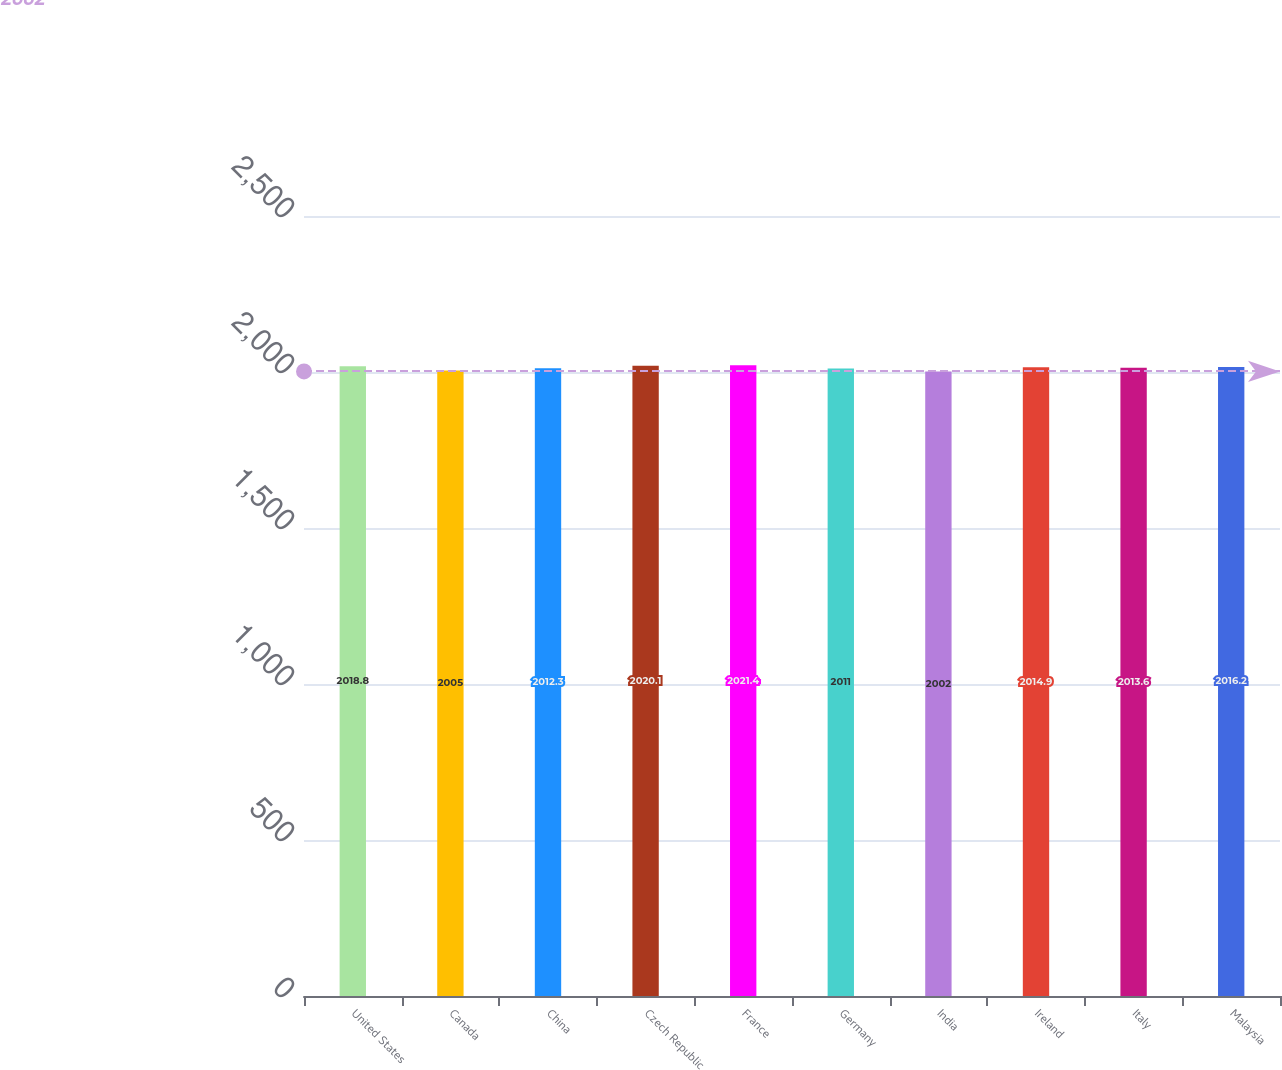Convert chart. <chart><loc_0><loc_0><loc_500><loc_500><bar_chart><fcel>United States<fcel>Canada<fcel>China<fcel>Czech Republic<fcel>France<fcel>Germany<fcel>India<fcel>Ireland<fcel>Italy<fcel>Malaysia<nl><fcel>2018.8<fcel>2005<fcel>2012.3<fcel>2020.1<fcel>2021.4<fcel>2011<fcel>2002<fcel>2014.9<fcel>2013.6<fcel>2016.2<nl></chart> 